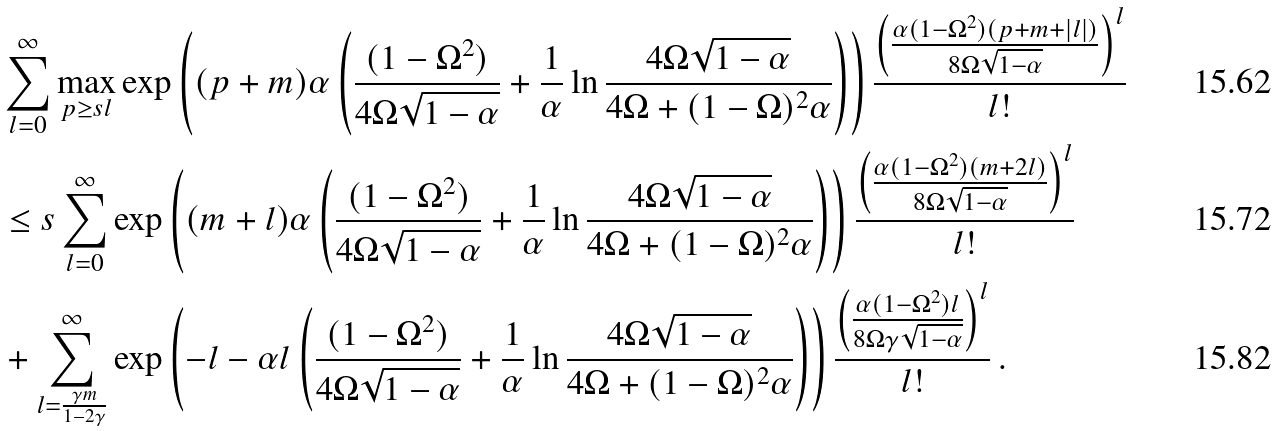Convert formula to latex. <formula><loc_0><loc_0><loc_500><loc_500>& \sum _ { l = 0 } ^ { \infty } \max _ { p \geq s l } \exp \left ( ( p + m ) \alpha \left ( \frac { ( 1 - \Omega ^ { 2 } ) } { 4 \Omega \sqrt { 1 - \alpha } } + \frac { 1 } { \alpha } \ln \frac { 4 \Omega \sqrt { 1 - \alpha } } { 4 \Omega + ( 1 - \Omega ) ^ { 2 } \alpha } \right ) \right ) \frac { \left ( \frac { \alpha ( 1 - \Omega ^ { 2 } ) ( p + m + | l | ) } { 8 \Omega \sqrt { 1 - \alpha } } \right ) ^ { l } } { l ! } \\ & \leq s \sum _ { l = 0 } ^ { \infty } \exp \left ( ( m + l ) \alpha \left ( \frac { ( 1 - \Omega ^ { 2 } ) } { 4 \Omega \sqrt { 1 - \alpha } } + \frac { 1 } { \alpha } \ln \frac { 4 \Omega \sqrt { 1 - \alpha } } { 4 \Omega + ( 1 - \Omega ) ^ { 2 } \alpha } \right ) \right ) \frac { \left ( \frac { \alpha ( 1 - \Omega ^ { 2 } ) ( m + 2 l ) } { 8 \Omega \sqrt { 1 - \alpha } } \right ) ^ { l } } { l ! } \\ & + \sum _ { l = \frac { \gamma m } { 1 - 2 \gamma } } ^ { \infty } \exp \left ( - l - \alpha l \left ( \frac { ( 1 - \Omega ^ { 2 } ) } { 4 \Omega \sqrt { 1 - \alpha } } + \frac { 1 } { \alpha } \ln \frac { 4 \Omega \sqrt { 1 - \alpha } } { 4 \Omega + ( 1 - \Omega ) ^ { 2 } \alpha } \right ) \right ) \frac { \left ( \frac { \alpha ( 1 - \Omega ^ { 2 } ) l } { 8 \Omega \gamma \sqrt { 1 - \alpha } } \right ) ^ { l } } { l ! } \, .</formula> 